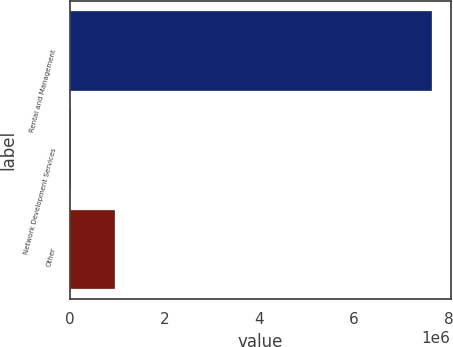Convert chart. <chart><loc_0><loc_0><loc_500><loc_500><bar_chart><fcel>Rental and Management<fcel>Network Development Services<fcel>Other<nl><fcel>7.6557e+06<fcel>20670<fcel>936848<nl></chart> 